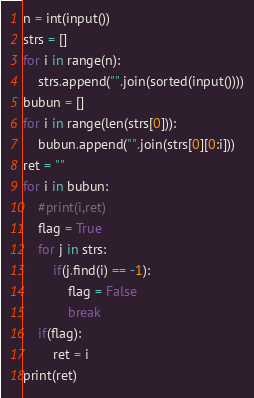Convert code to text. <code><loc_0><loc_0><loc_500><loc_500><_Python_>n = int(input())
strs = []
for i in range(n):
    strs.append("".join(sorted(input())))
bubun = []
for i in range(len(strs[0])):
    bubun.append("".join(strs[0][0:i]))
ret = ""
for i in bubun:
    #print(i,ret)
    flag = True
    for j in strs:
        if(j.find(i) == -1):
            flag = False
            break
    if(flag):
        ret = i
print(ret)
</code> 